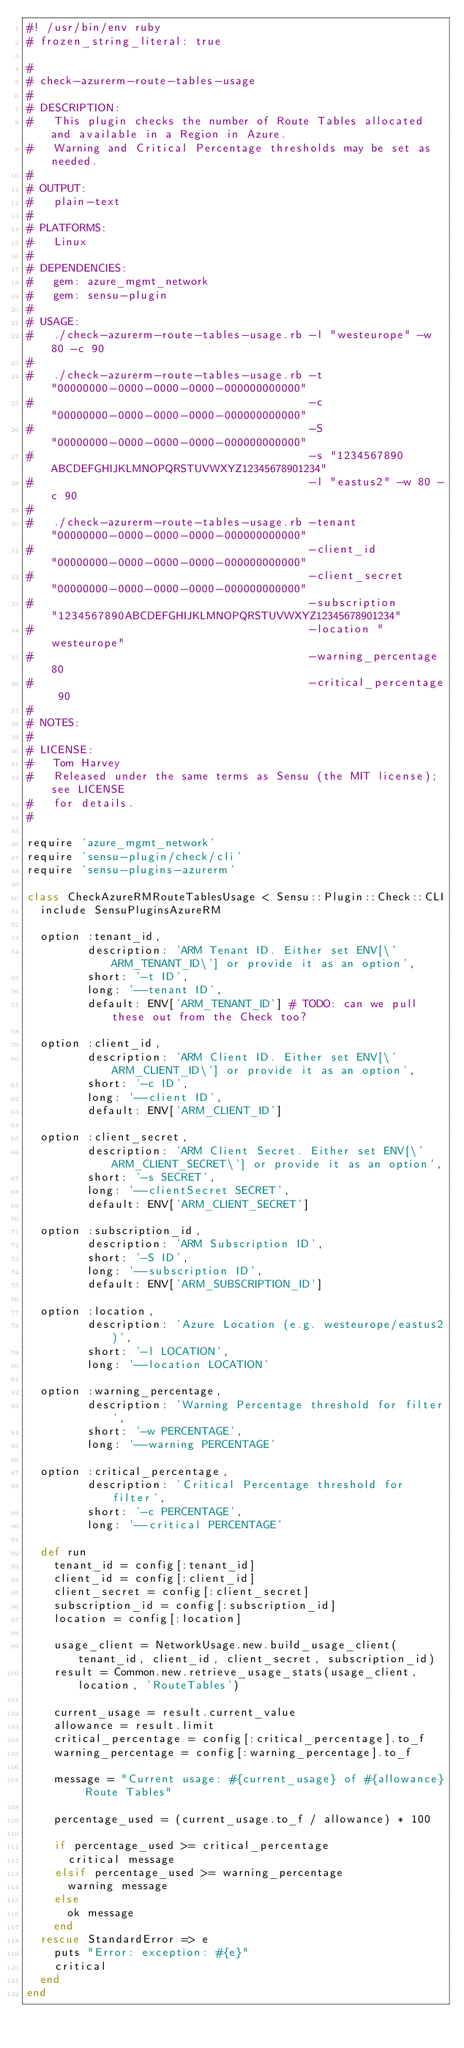<code> <loc_0><loc_0><loc_500><loc_500><_Ruby_>#! /usr/bin/env ruby
# frozen_string_literal: true

#
# check-azurerm-route-tables-usage
#
# DESCRIPTION:
#   This plugin checks the number of Route Tables allocated and available in a Region in Azure.
#   Warning and Critical Percentage thresholds may be set as needed.
#
# OUTPUT:
#   plain-text
#
# PLATFORMS:
#   Linux
#
# DEPENDENCIES:
#   gem: azure_mgmt_network
#   gem: sensu-plugin
#
# USAGE:
#   ./check-azurerm-route-tables-usage.rb -l "westeurope" -w 80 -c 90
#
#   ./check-azurerm-route-tables-usage.rb -t "00000000-0000-0000-0000-000000000000"
#                                         -c "00000000-0000-0000-0000-000000000000"
#                                         -S "00000000-0000-0000-0000-000000000000"
#                                         -s "1234567890ABCDEFGHIJKLMNOPQRSTUVWXYZ12345678901234"
#                                         -l "eastus2" -w 80 -c 90
#
#   ./check-azurerm-route-tables-usage.rb -tenant "00000000-0000-0000-0000-000000000000"
#                                         -client_id "00000000-0000-0000-0000-000000000000"
#                                         -client_secret "00000000-0000-0000-0000-000000000000"
#                                         -subscription "1234567890ABCDEFGHIJKLMNOPQRSTUVWXYZ12345678901234"
#                                         -location "westeurope"
#                                         -warning_percentage 80
#                                         -critical_percentage 90
#
# NOTES:
#
# LICENSE:
#   Tom Harvey
#   Released under the same terms as Sensu (the MIT license); see LICENSE
#   for details.
#

require 'azure_mgmt_network'
require 'sensu-plugin/check/cli'
require 'sensu-plugins-azurerm'

class CheckAzureRMRouteTablesUsage < Sensu::Plugin::Check::CLI
  include SensuPluginsAzureRM

  option :tenant_id,
         description: 'ARM Tenant ID. Either set ENV[\'ARM_TENANT_ID\'] or provide it as an option',
         short: '-t ID',
         long: '--tenant ID',
         default: ENV['ARM_TENANT_ID'] # TODO: can we pull these out from the Check too?

  option :client_id,
         description: 'ARM Client ID. Either set ENV[\'ARM_CLIENT_ID\'] or provide it as an option',
         short: '-c ID',
         long: '--client ID',
         default: ENV['ARM_CLIENT_ID']

  option :client_secret,
         description: 'ARM Client Secret. Either set ENV[\'ARM_CLIENT_SECRET\'] or provide it as an option',
         short: '-s SECRET',
         long: '--clientSecret SECRET',
         default: ENV['ARM_CLIENT_SECRET']

  option :subscription_id,
         description: 'ARM Subscription ID',
         short: '-S ID',
         long: '--subscription ID',
         default: ENV['ARM_SUBSCRIPTION_ID']

  option :location,
         description: 'Azure Location (e.g. westeurope/eastus2)',
         short: '-l LOCATION',
         long: '--location LOCATION'

  option :warning_percentage,
         description: 'Warning Percentage threshold for filter',
         short: '-w PERCENTAGE',
         long: '--warning PERCENTAGE'

  option :critical_percentage,
         description: 'Critical Percentage threshold for filter',
         short: '-c PERCENTAGE',
         long: '--critical PERCENTAGE'

  def run
    tenant_id = config[:tenant_id]
    client_id = config[:client_id]
    client_secret = config[:client_secret]
    subscription_id = config[:subscription_id]
    location = config[:location]

    usage_client = NetworkUsage.new.build_usage_client(tenant_id, client_id, client_secret, subscription_id)
    result = Common.new.retrieve_usage_stats(usage_client, location, 'RouteTables')

    current_usage = result.current_value
    allowance = result.limit
    critical_percentage = config[:critical_percentage].to_f
    warning_percentage = config[:warning_percentage].to_f

    message = "Current usage: #{current_usage} of #{allowance} Route Tables"

    percentage_used = (current_usage.to_f / allowance) * 100

    if percentage_used >= critical_percentage
      critical message
    elsif percentage_used >= warning_percentage
      warning message
    else
      ok message
    end
  rescue StandardError => e
    puts "Error: exception: #{e}"
    critical
  end
end
</code> 